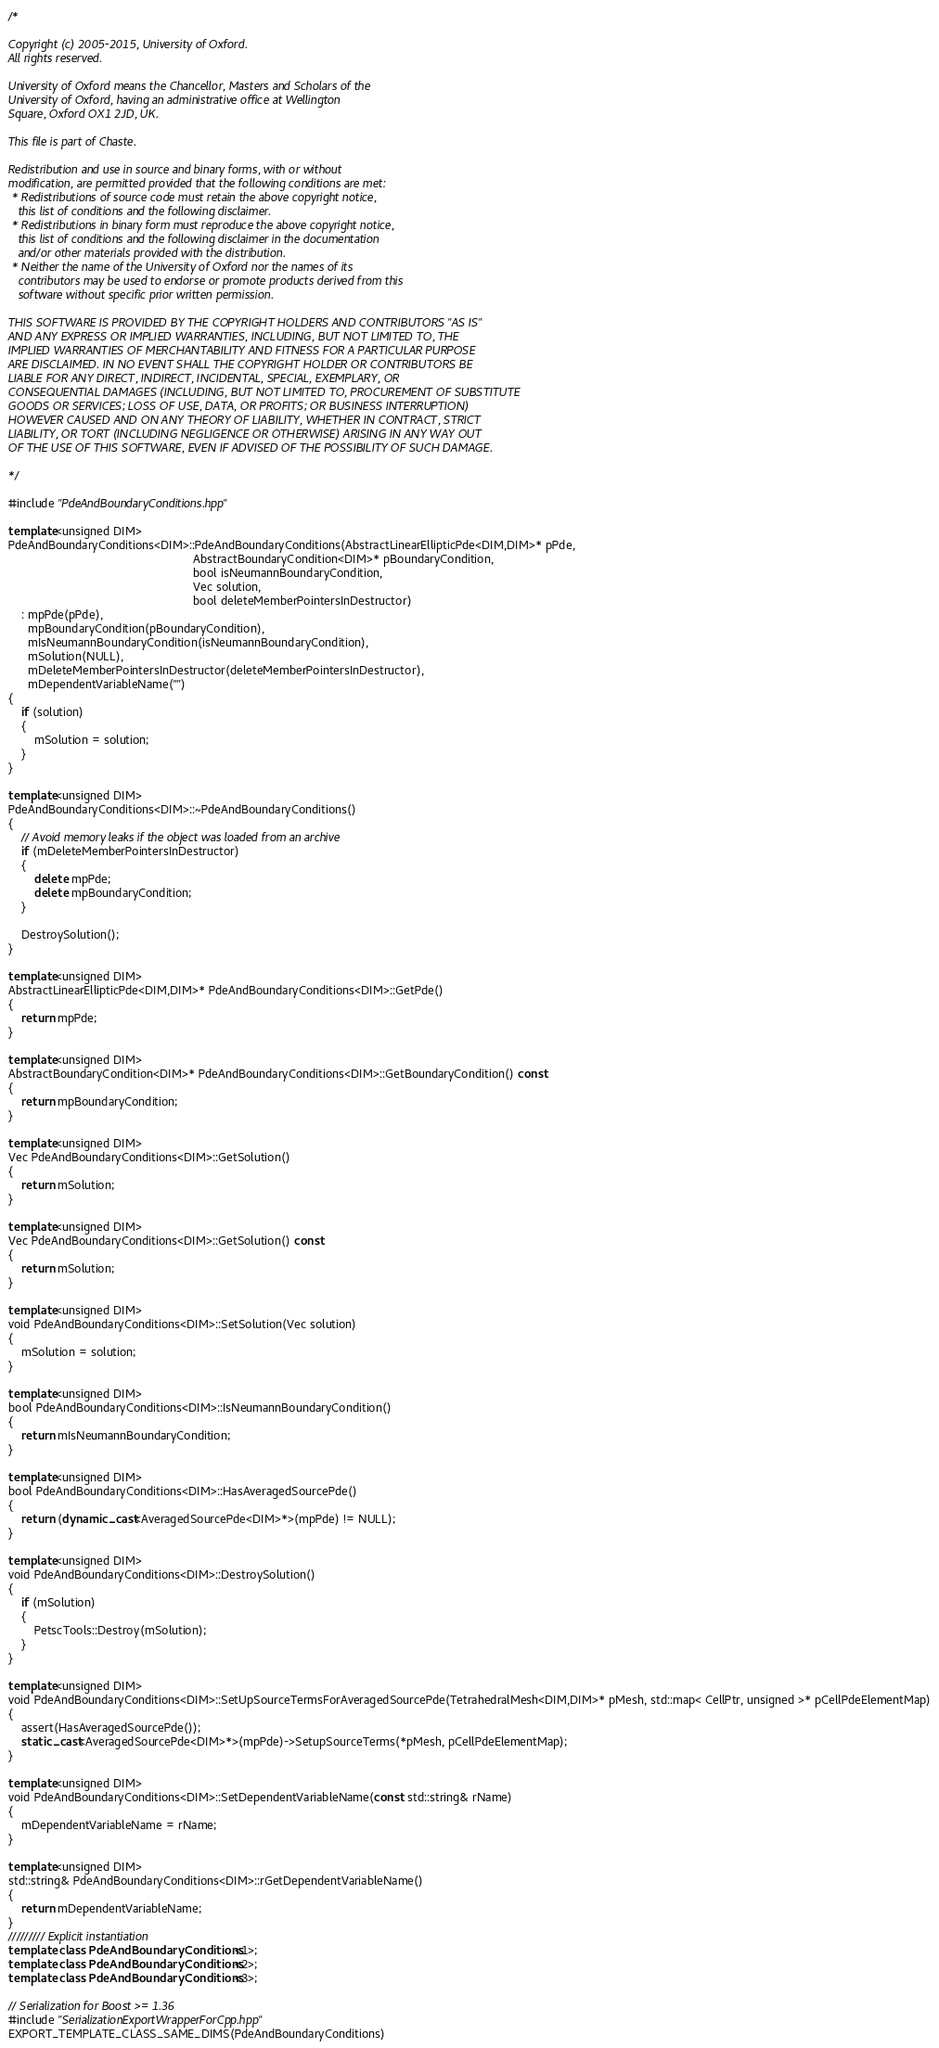Convert code to text. <code><loc_0><loc_0><loc_500><loc_500><_C++_>/*

Copyright (c) 2005-2015, University of Oxford.
All rights reserved.

University of Oxford means the Chancellor, Masters and Scholars of the
University of Oxford, having an administrative office at Wellington
Square, Oxford OX1 2JD, UK.

This file is part of Chaste.

Redistribution and use in source and binary forms, with or without
modification, are permitted provided that the following conditions are met:
 * Redistributions of source code must retain the above copyright notice,
   this list of conditions and the following disclaimer.
 * Redistributions in binary form must reproduce the above copyright notice,
   this list of conditions and the following disclaimer in the documentation
   and/or other materials provided with the distribution.
 * Neither the name of the University of Oxford nor the names of its
   contributors may be used to endorse or promote products derived from this
   software without specific prior written permission.

THIS SOFTWARE IS PROVIDED BY THE COPYRIGHT HOLDERS AND CONTRIBUTORS "AS IS"
AND ANY EXPRESS OR IMPLIED WARRANTIES, INCLUDING, BUT NOT LIMITED TO, THE
IMPLIED WARRANTIES OF MERCHANTABILITY AND FITNESS FOR A PARTICULAR PURPOSE
ARE DISCLAIMED. IN NO EVENT SHALL THE COPYRIGHT HOLDER OR CONTRIBUTORS BE
LIABLE FOR ANY DIRECT, INDIRECT, INCIDENTAL, SPECIAL, EXEMPLARY, OR
CONSEQUENTIAL DAMAGES (INCLUDING, BUT NOT LIMITED TO, PROCUREMENT OF SUBSTITUTE
GOODS OR SERVICES; LOSS OF USE, DATA, OR PROFITS; OR BUSINESS INTERRUPTION)
HOWEVER CAUSED AND ON ANY THEORY OF LIABILITY, WHETHER IN CONTRACT, STRICT
LIABILITY, OR TORT (INCLUDING NEGLIGENCE OR OTHERWISE) ARISING IN ANY WAY OUT
OF THE USE OF THIS SOFTWARE, EVEN IF ADVISED OF THE POSSIBILITY OF SUCH DAMAGE.

*/

#include "PdeAndBoundaryConditions.hpp"

template<unsigned DIM>
PdeAndBoundaryConditions<DIM>::PdeAndBoundaryConditions(AbstractLinearEllipticPde<DIM,DIM>* pPde,
                                                        AbstractBoundaryCondition<DIM>* pBoundaryCondition,
                                                        bool isNeumannBoundaryCondition,
                                                        Vec solution,
                                                        bool deleteMemberPointersInDestructor)
    : mpPde(pPde),
      mpBoundaryCondition(pBoundaryCondition),
      mIsNeumannBoundaryCondition(isNeumannBoundaryCondition),
      mSolution(NULL),
      mDeleteMemberPointersInDestructor(deleteMemberPointersInDestructor),
      mDependentVariableName("")
{
    if (solution)
    {
        mSolution = solution;
    }
}

template<unsigned DIM>
PdeAndBoundaryConditions<DIM>::~PdeAndBoundaryConditions()
{
    // Avoid memory leaks if the object was loaded from an archive
    if (mDeleteMemberPointersInDestructor)
    {
        delete mpPde;
        delete mpBoundaryCondition;
    }

    DestroySolution();
}

template<unsigned DIM>
AbstractLinearEllipticPde<DIM,DIM>* PdeAndBoundaryConditions<DIM>::GetPde()
{
    return mpPde;
}

template<unsigned DIM>
AbstractBoundaryCondition<DIM>* PdeAndBoundaryConditions<DIM>::GetBoundaryCondition() const
{
    return mpBoundaryCondition;
}

template<unsigned DIM>
Vec PdeAndBoundaryConditions<DIM>::GetSolution()
{
    return mSolution;
}

template<unsigned DIM>
Vec PdeAndBoundaryConditions<DIM>::GetSolution() const
{
    return mSolution;
}

template<unsigned DIM>
void PdeAndBoundaryConditions<DIM>::SetSolution(Vec solution)
{
    mSolution = solution;
}

template<unsigned DIM>
bool PdeAndBoundaryConditions<DIM>::IsNeumannBoundaryCondition()
{
    return mIsNeumannBoundaryCondition;
}

template<unsigned DIM>
bool PdeAndBoundaryConditions<DIM>::HasAveragedSourcePde()
{
    return (dynamic_cast<AveragedSourcePde<DIM>*>(mpPde) != NULL);
}

template<unsigned DIM>
void PdeAndBoundaryConditions<DIM>::DestroySolution()
{
    if (mSolution)
    {
        PetscTools::Destroy(mSolution);
    }
}

template<unsigned DIM>
void PdeAndBoundaryConditions<DIM>::SetUpSourceTermsForAveragedSourcePde(TetrahedralMesh<DIM,DIM>* pMesh, std::map< CellPtr, unsigned >* pCellPdeElementMap)
{
    assert(HasAveragedSourcePde());
    static_cast<AveragedSourcePde<DIM>*>(mpPde)->SetupSourceTerms(*pMesh, pCellPdeElementMap);
}

template<unsigned DIM>
void PdeAndBoundaryConditions<DIM>::SetDependentVariableName(const std::string& rName)
{
    mDependentVariableName = rName;
}

template<unsigned DIM>
std::string& PdeAndBoundaryConditions<DIM>::rGetDependentVariableName()
{
    return mDependentVariableName;
}
///////// Explicit instantiation
template class PdeAndBoundaryConditions<1>;
template class PdeAndBoundaryConditions<2>;
template class PdeAndBoundaryConditions<3>;

// Serialization for Boost >= 1.36
#include "SerializationExportWrapperForCpp.hpp"
EXPORT_TEMPLATE_CLASS_SAME_DIMS(PdeAndBoundaryConditions)
</code> 